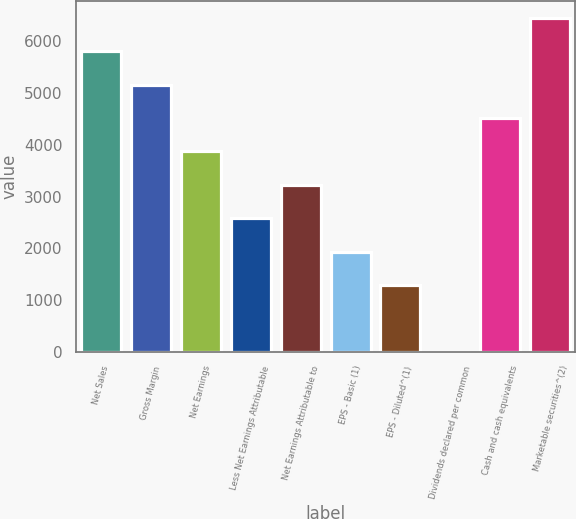Convert chart to OTSL. <chart><loc_0><loc_0><loc_500><loc_500><bar_chart><fcel>Net Sales<fcel>Gross Margin<fcel>Net Earnings<fcel>Less Net Earnings Attributable<fcel>Net Earnings Attributable to<fcel>EPS - Basic (1)<fcel>EPS - Diluted^(1)<fcel>Dividends declared per common<fcel>Cash and cash equivalents<fcel>Marketable securities^(2)<nl><fcel>5807.76<fcel>5162.49<fcel>3871.95<fcel>2581.41<fcel>3226.68<fcel>1936.14<fcel>1290.87<fcel>0.33<fcel>4517.22<fcel>6453.03<nl></chart> 